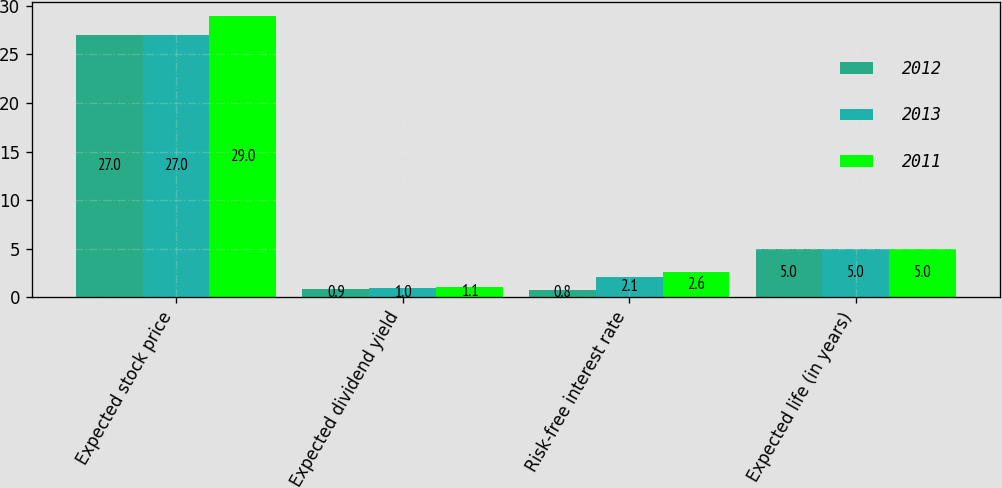Convert chart. <chart><loc_0><loc_0><loc_500><loc_500><stacked_bar_chart><ecel><fcel>Expected stock price<fcel>Expected dividend yield<fcel>Risk-free interest rate<fcel>Expected life (in years)<nl><fcel>2012<fcel>27<fcel>0.9<fcel>0.8<fcel>5<nl><fcel>2013<fcel>27<fcel>1<fcel>2.1<fcel>5<nl><fcel>2011<fcel>29<fcel>1.1<fcel>2.6<fcel>5<nl></chart> 